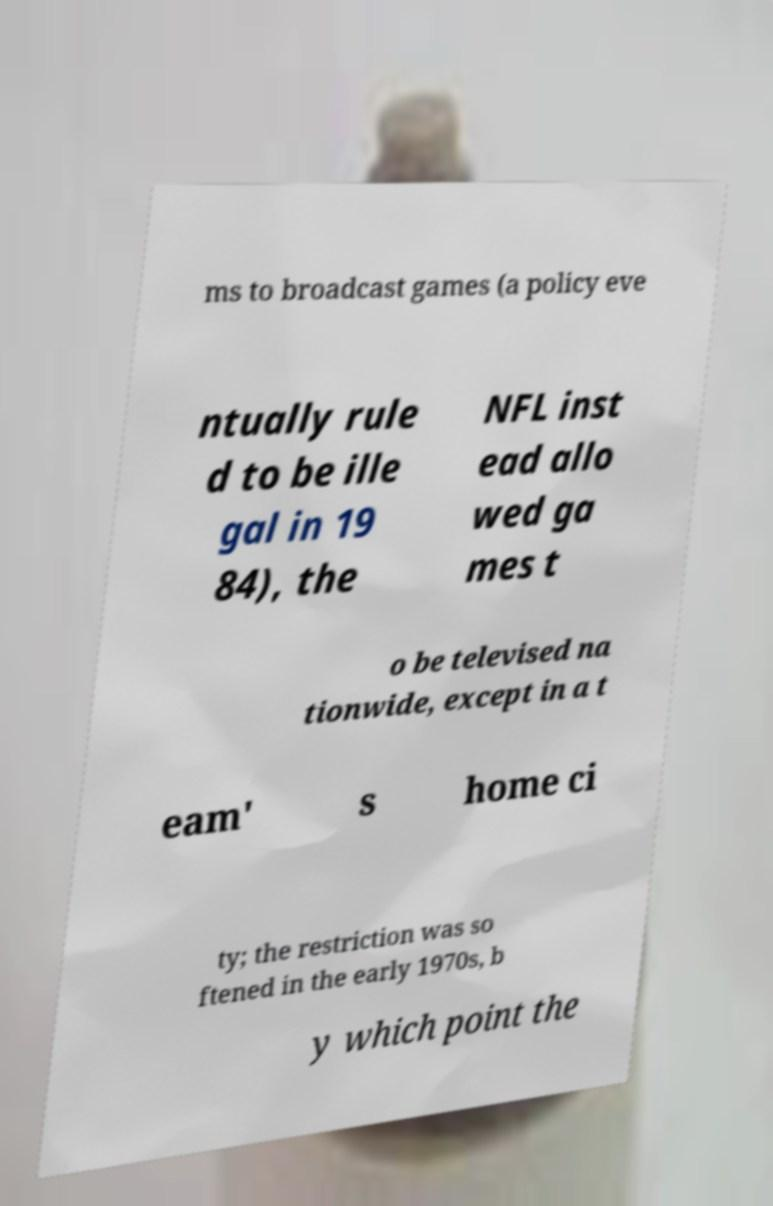Could you extract and type out the text from this image? ms to broadcast games (a policy eve ntually rule d to be ille gal in 19 84), the NFL inst ead allo wed ga mes t o be televised na tionwide, except in a t eam' s home ci ty; the restriction was so ftened in the early 1970s, b y which point the 